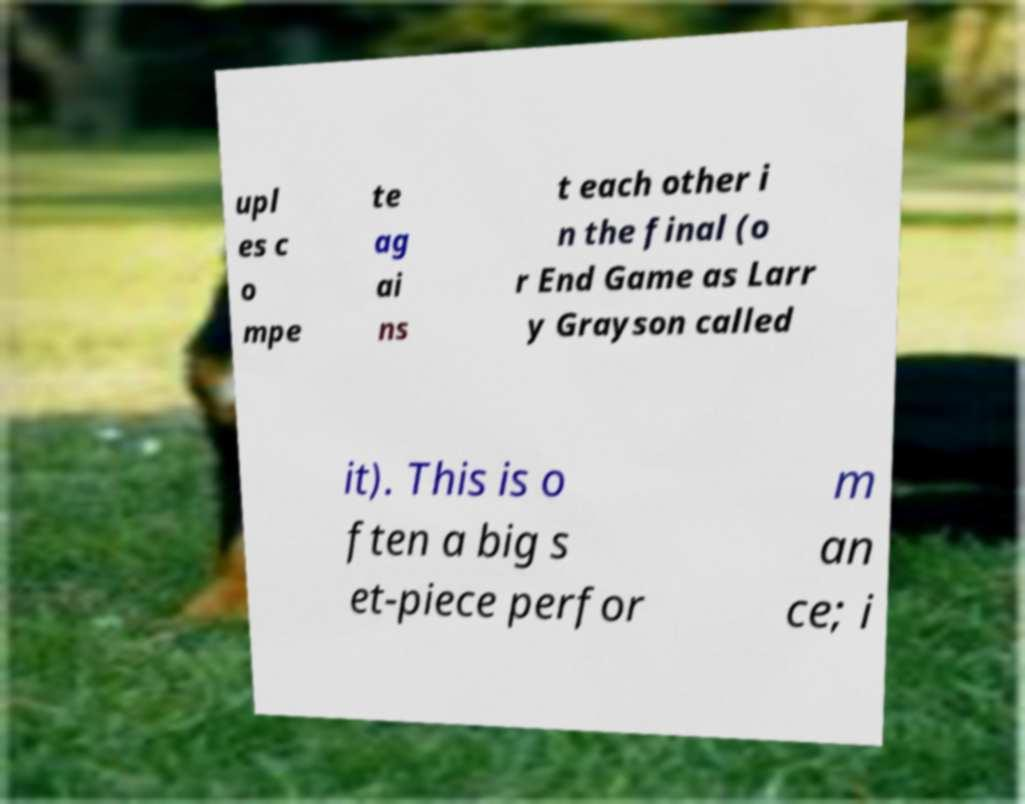I need the written content from this picture converted into text. Can you do that? upl es c o mpe te ag ai ns t each other i n the final (o r End Game as Larr y Grayson called it). This is o ften a big s et-piece perfor m an ce; i 